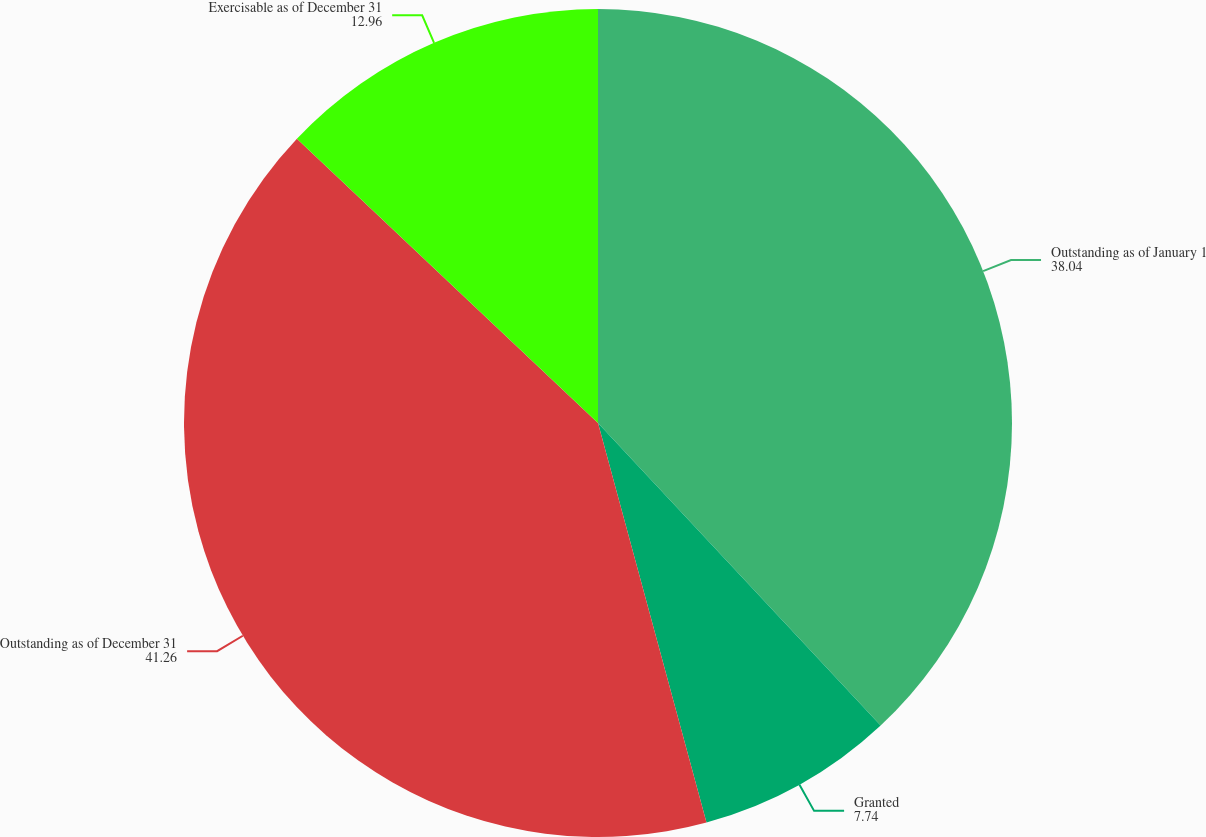<chart> <loc_0><loc_0><loc_500><loc_500><pie_chart><fcel>Outstanding as of January 1<fcel>Granted<fcel>Outstanding as of December 31<fcel>Exercisable as of December 31<nl><fcel>38.04%<fcel>7.74%<fcel>41.26%<fcel>12.96%<nl></chart> 